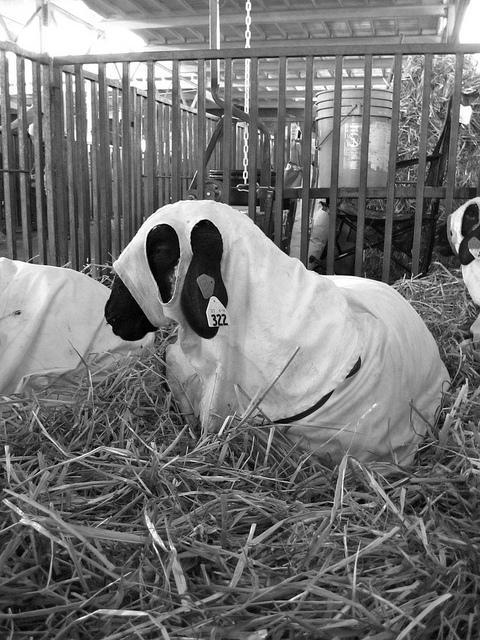The first digit of the number that is clipped to the ear is included in what number?
Make your selection and explain in format: 'Answer: answer
Rationale: rationale.'
Options: 444, 280, 515, 305. Answer: 305.
Rationale: The first digit is 305. 